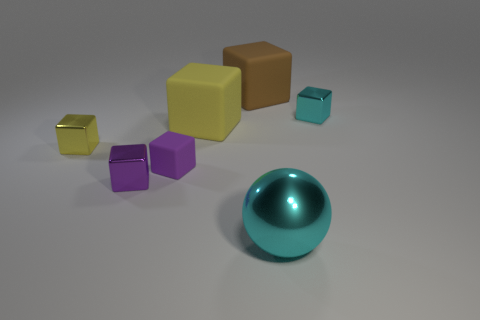Subtract all small purple shiny blocks. How many blocks are left? 5 Add 2 small green rubber blocks. How many objects exist? 9 Subtract all yellow cubes. How many cubes are left? 4 Subtract 1 balls. How many balls are left? 0 Subtract all cyan blocks. How many red balls are left? 0 Subtract all yellow matte blocks. Subtract all cyan metal cubes. How many objects are left? 5 Add 1 small purple metal objects. How many small purple metal objects are left? 2 Add 6 big cubes. How many big cubes exist? 8 Subtract 0 yellow spheres. How many objects are left? 7 Subtract all blocks. How many objects are left? 1 